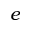<formula> <loc_0><loc_0><loc_500><loc_500>e</formula> 